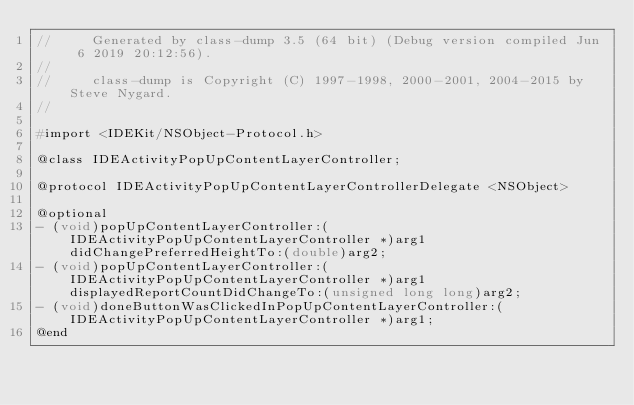<code> <loc_0><loc_0><loc_500><loc_500><_C_>//     Generated by class-dump 3.5 (64 bit) (Debug version compiled Jun  6 2019 20:12:56).
//
//     class-dump is Copyright (C) 1997-1998, 2000-2001, 2004-2015 by Steve Nygard.
//

#import <IDEKit/NSObject-Protocol.h>

@class IDEActivityPopUpContentLayerController;

@protocol IDEActivityPopUpContentLayerControllerDelegate <NSObject>

@optional
- (void)popUpContentLayerController:(IDEActivityPopUpContentLayerController *)arg1 didChangePreferredHeightTo:(double)arg2;
- (void)popUpContentLayerController:(IDEActivityPopUpContentLayerController *)arg1 displayedReportCountDidChangeTo:(unsigned long long)arg2;
- (void)doneButtonWasClickedInPopUpContentLayerController:(IDEActivityPopUpContentLayerController *)arg1;
@end

</code> 